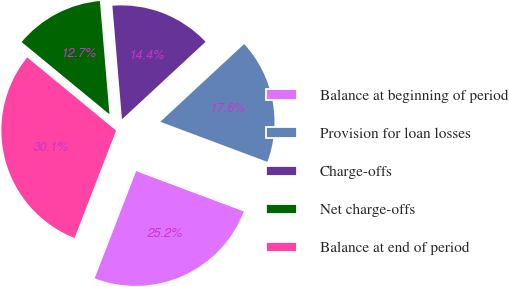Convert chart. <chart><loc_0><loc_0><loc_500><loc_500><pie_chart><fcel>Balance at beginning of period<fcel>Provision for loan losses<fcel>Charge-offs<fcel>Net charge-offs<fcel>Balance at end of period<nl><fcel>25.18%<fcel>17.6%<fcel>14.44%<fcel>12.7%<fcel>30.08%<nl></chart> 